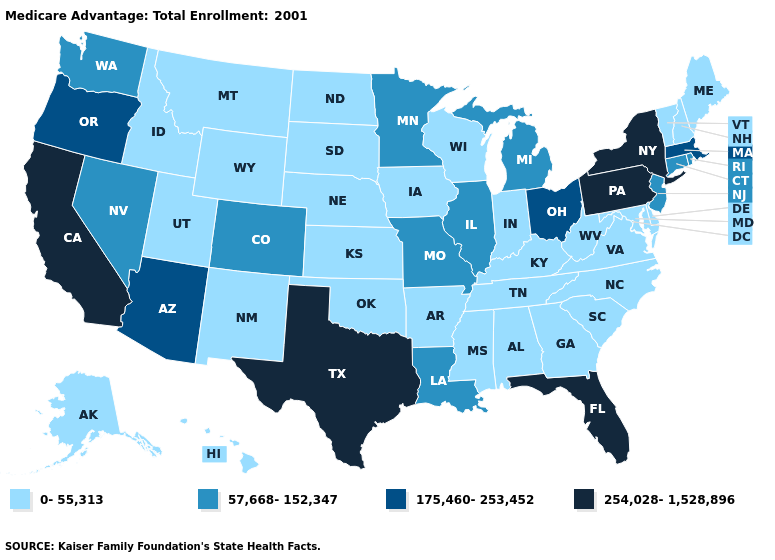Does Pennsylvania have the same value as New York?
Give a very brief answer. Yes. Name the states that have a value in the range 175,460-253,452?
Be succinct. Arizona, Massachusetts, Ohio, Oregon. Does the first symbol in the legend represent the smallest category?
Answer briefly. Yes. What is the value of New Mexico?
Quick response, please. 0-55,313. Does New Mexico have a higher value than Wyoming?
Give a very brief answer. No. Which states have the lowest value in the West?
Write a very short answer. Alaska, Hawaii, Idaho, Montana, New Mexico, Utah, Wyoming. Which states have the lowest value in the South?
Be succinct. Alabama, Arkansas, Delaware, Georgia, Kentucky, Maryland, Mississippi, North Carolina, Oklahoma, South Carolina, Tennessee, Virginia, West Virginia. Among the states that border South Carolina , which have the lowest value?
Short answer required. Georgia, North Carolina. Name the states that have a value in the range 0-55,313?
Keep it brief. Alaska, Alabama, Arkansas, Delaware, Georgia, Hawaii, Iowa, Idaho, Indiana, Kansas, Kentucky, Maryland, Maine, Mississippi, Montana, North Carolina, North Dakota, Nebraska, New Hampshire, New Mexico, Oklahoma, South Carolina, South Dakota, Tennessee, Utah, Virginia, Vermont, Wisconsin, West Virginia, Wyoming. Does the map have missing data?
Answer briefly. No. Does Virginia have the same value as Alabama?
Answer briefly. Yes. Name the states that have a value in the range 175,460-253,452?
Be succinct. Arizona, Massachusetts, Ohio, Oregon. What is the value of Maine?
Short answer required. 0-55,313. Which states have the lowest value in the West?
Answer briefly. Alaska, Hawaii, Idaho, Montana, New Mexico, Utah, Wyoming. How many symbols are there in the legend?
Keep it brief. 4. 